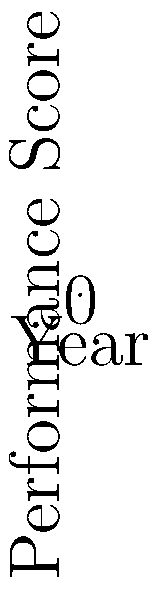Based on the line graph showing program performance trends from 2018 to 2022, which program demonstrates the most consistent upward trend, and what strategic decision would you recommend to optimize overall department performance? To answer this question, we need to analyze the trends for each program:

1. Program A (blue line):
   - Shows a consistent upward trend from 85 in 2018 to 98 in 2022
   - Increase of 13 points over 5 years
   - No dips or plateaus in performance

2. Program B (red line):
   - Overall upward trend, but with fluctuations
   - Starts at 80 in 2018, drops to 79 in 2020, then rises to 87 in 2022
   - Increase of 7 points over 5 years, but less consistent

3. Program C (green line):
   - Fluctuating performance
   - Starts at 90 in 2018, drops to 86 in 2020, then rises to 91 in 2022
   - Overall increase of only 1 point over 5 years

Program A demonstrates the most consistent upward trend, with steady improvement each year and the highest overall gain.

Strategic decision recommendation:
1. Allocate more resources to Program A to capitalize on its consistent growth
2. Investigate and apply successful strategies from Program A to Programs B and C
3. Analyze factors causing fluctuations in Programs B and C to stabilize their performance
4. Consider reallocating resources from underperforming programs to Program A if budget constraints exist

This approach optimizes overall department performance by:
- Reinforcing successful strategies
- Addressing inconsistencies in other programs
- Efficiently allocating resources based on performance trends
Answer: Program A; Allocate more resources to Program A while applying its successful strategies to Programs B and C. 